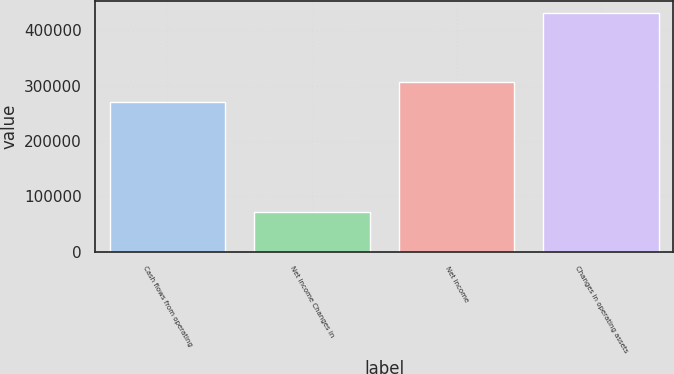Convert chart. <chart><loc_0><loc_0><loc_500><loc_500><bar_chart><fcel>Cash flows from operating<fcel>Net income Changes in<fcel>Net income<fcel>Changes in operating assets<nl><fcel>269665<fcel>72610<fcel>305527<fcel>431232<nl></chart> 